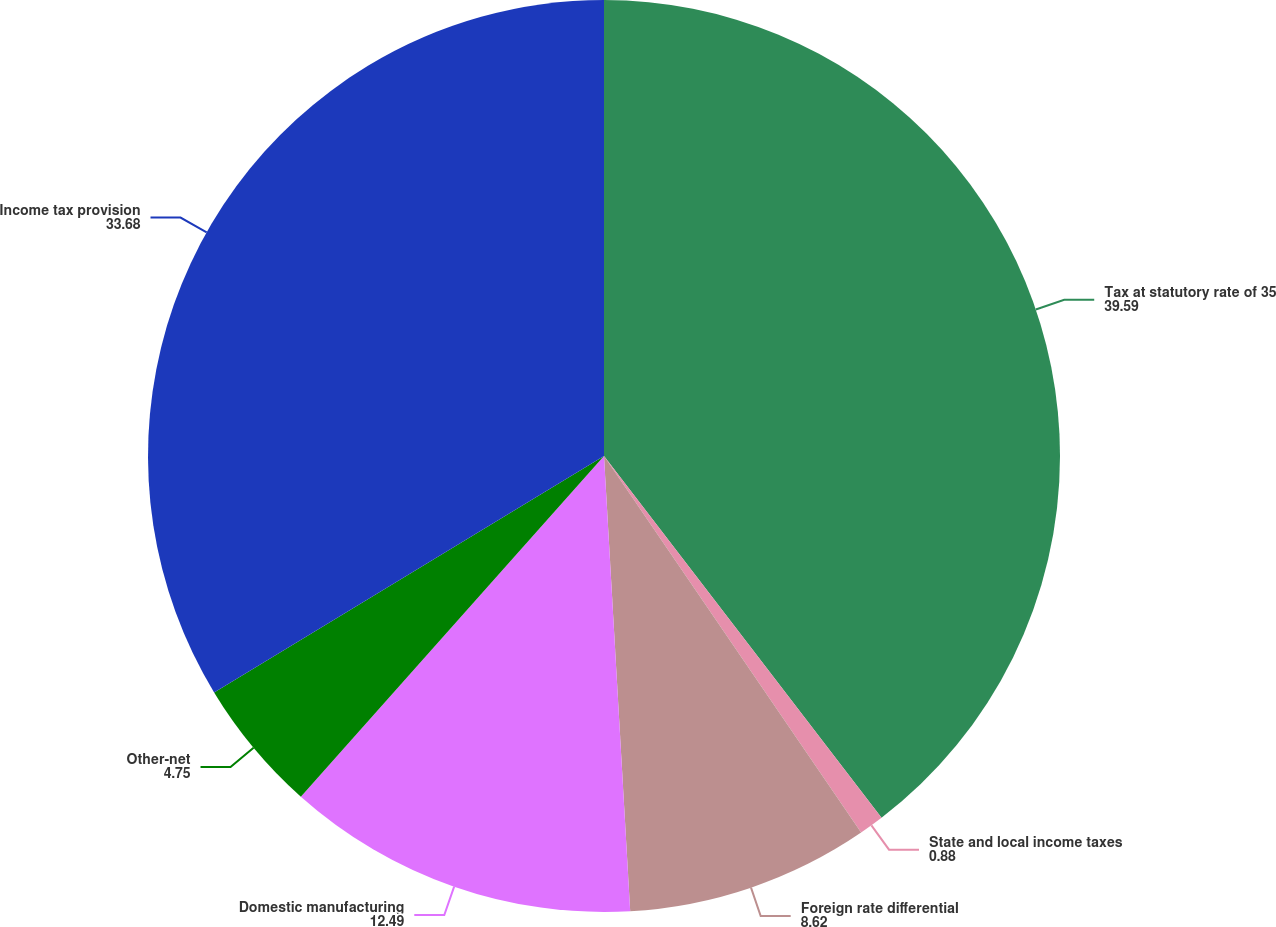Convert chart. <chart><loc_0><loc_0><loc_500><loc_500><pie_chart><fcel>Tax at statutory rate of 35<fcel>State and local income taxes<fcel>Foreign rate differential<fcel>Domestic manufacturing<fcel>Other-net<fcel>Income tax provision<nl><fcel>39.59%<fcel>0.88%<fcel>8.62%<fcel>12.49%<fcel>4.75%<fcel>33.68%<nl></chart> 